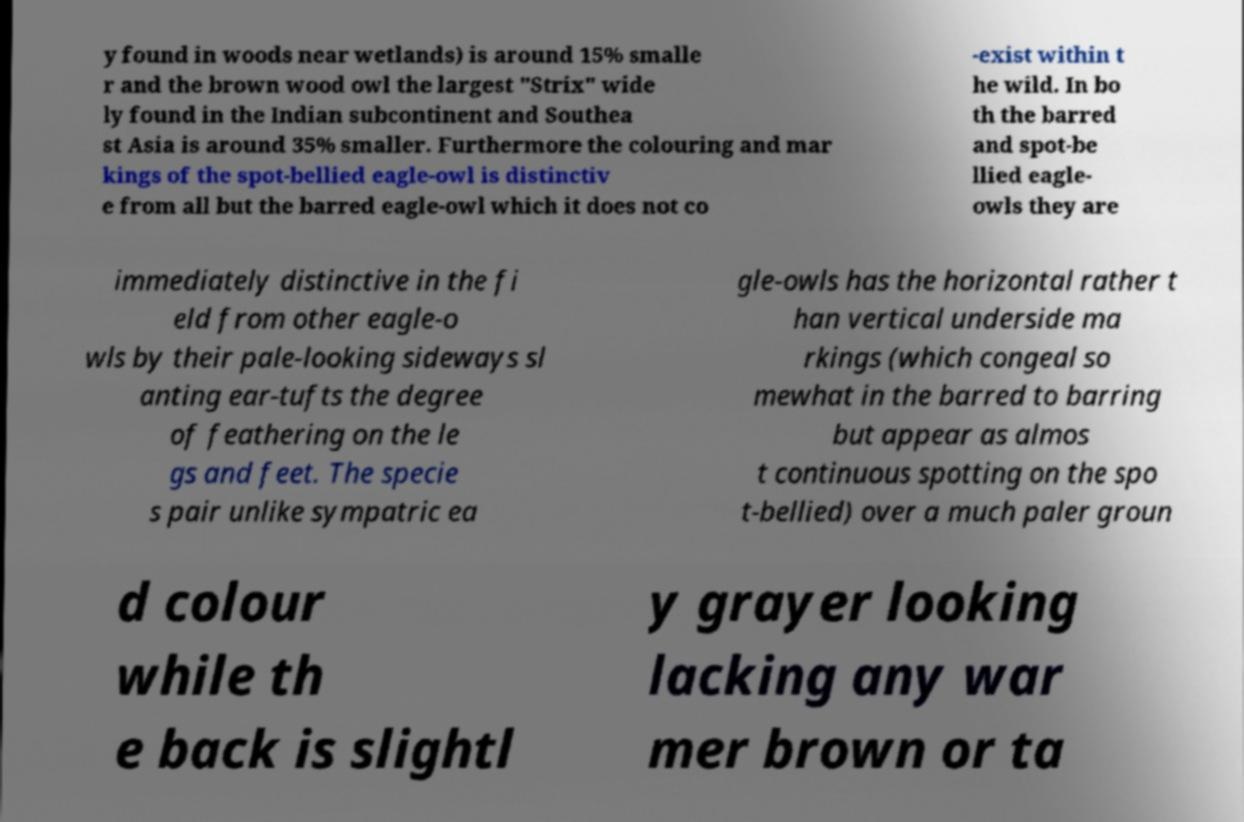Please identify and transcribe the text found in this image. y found in woods near wetlands) is around 15% smalle r and the brown wood owl the largest "Strix" wide ly found in the Indian subcontinent and Southea st Asia is around 35% smaller. Furthermore the colouring and mar kings of the spot-bellied eagle-owl is distinctiv e from all but the barred eagle-owl which it does not co -exist within t he wild. In bo th the barred and spot-be llied eagle- owls they are immediately distinctive in the fi eld from other eagle-o wls by their pale-looking sideways sl anting ear-tufts the degree of feathering on the le gs and feet. The specie s pair unlike sympatric ea gle-owls has the horizontal rather t han vertical underside ma rkings (which congeal so mewhat in the barred to barring but appear as almos t continuous spotting on the spo t-bellied) over a much paler groun d colour while th e back is slightl y grayer looking lacking any war mer brown or ta 